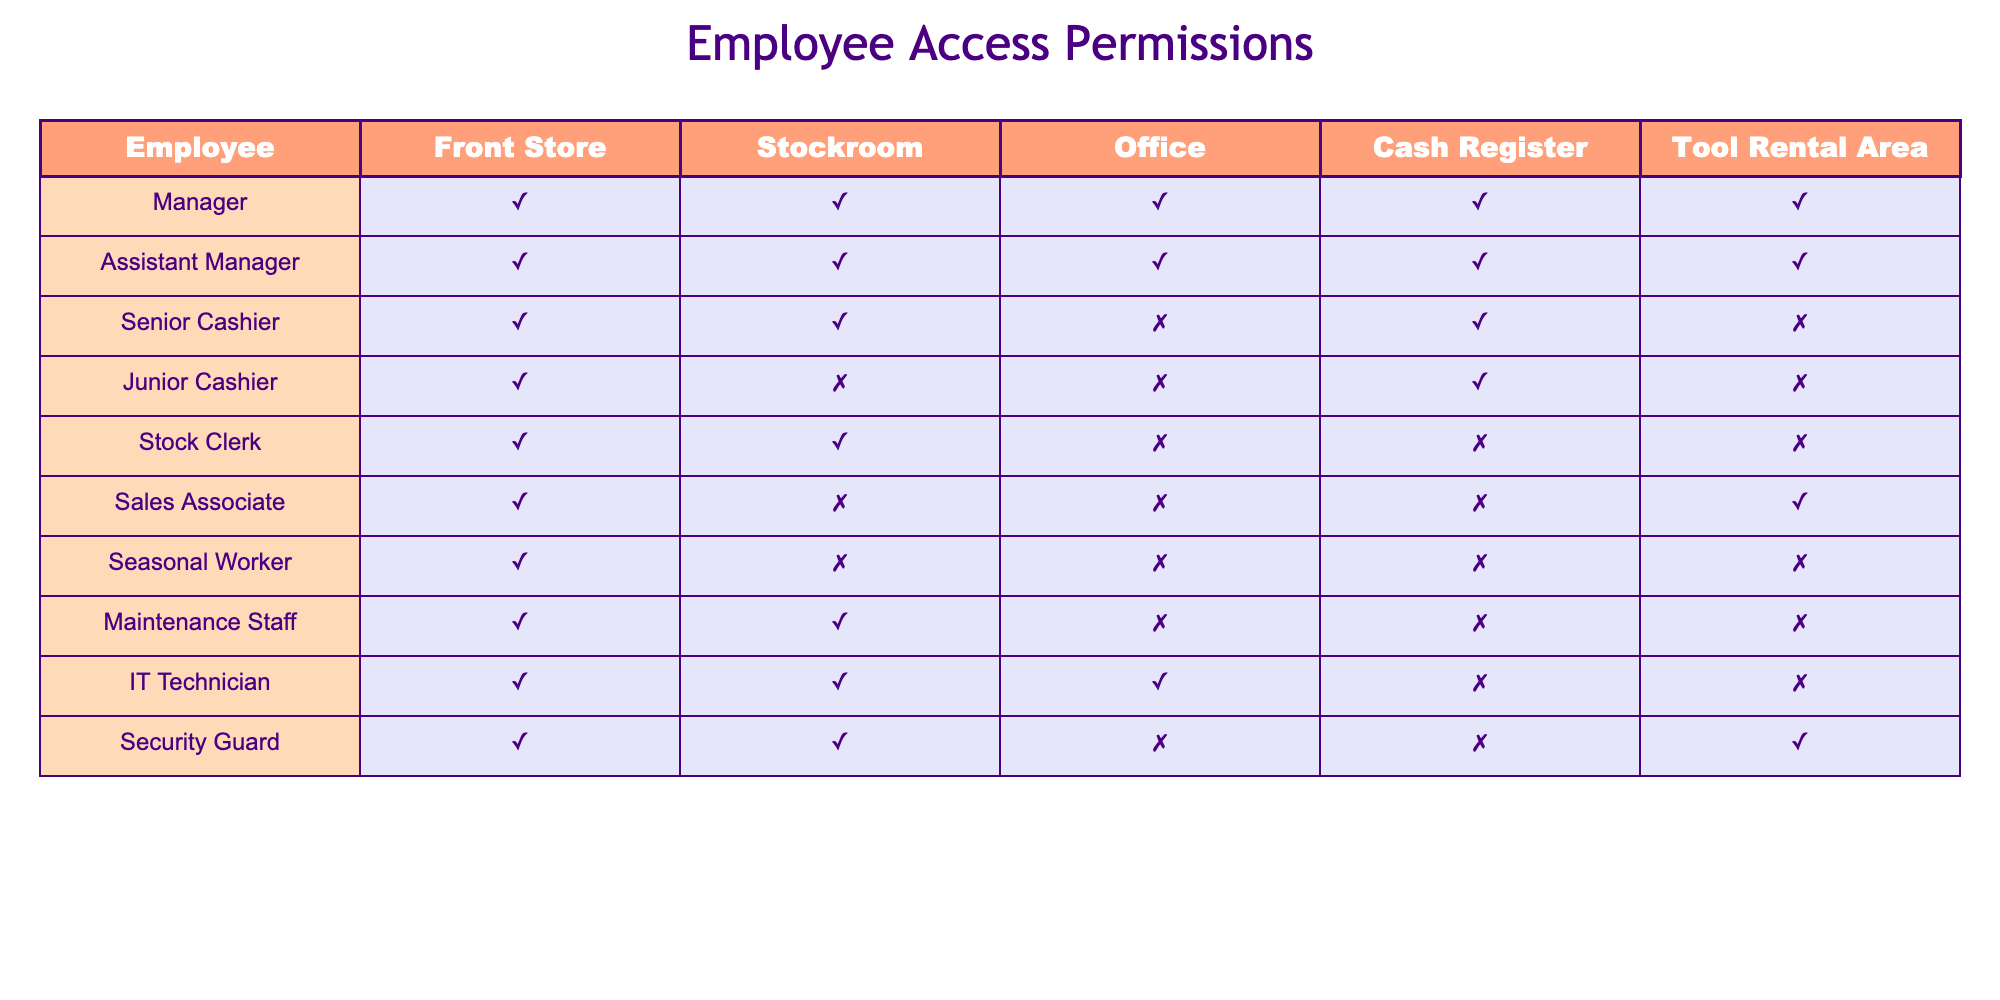What areas can the Senior Cashier access? The table shows that the Senior Cashier has access to the Front Store, Stockroom, and Cash Register, but not to the Office or Tool Rental Area.
Answer: Front Store, Stockroom, Cash Register Does the Security Guard have access to the Tool Rental Area? Looking at the table, the Security Guard has access marked as 'TRUE' for the Tool Rental Area, which means they can access it.
Answer: Yes How many employees can access the Office? From the table, the employees with access to the Office are the Manager, Assistant Manager, and IT Technician. Counting these, we find there are 3 employees.
Answer: 3 Which employee has access to both the Stockroom and the Cash Register? The table indicates that the Manager, Assistant Manager, and Stock Clerk have access to both the Stockroom and the Cash Register. This requires cross-referencing the related columns for those employees.
Answer: Manager, Assistant Manager, Stock Clerk Is the Junior Cashier allowed in the Stockroom? According to the data, the Junior Cashier does not have access to the Stockroom, as indicated by 'FALSE' in that column.
Answer: No Which employee has the most access to areas? By reviewing the table, we see that both the Manager and Assistant Manager have access to all areas, marking 'TRUE' for every access. This requires looking at all permissions for each employee.
Answer: Manager, Assistant Manager How many total areas can the Maintenance Staff access? The Maintenance Staff have access to the Front Store and Stockroom only. Counting those areas gives a total of 2.
Answer: 2 Are there any employees who do not have access to the Cash Register? From the table, the Junior Cashier, Stock Clerk, Seasonal Worker, and the IT Technician do not have access to the Cash Register, as their values are marked 'FALSE'.
Answer: Yes If we combine access to the Front Store and Tool Rental Area, how many unique employees have that access? By reviewing the table, the employees who have access to the Front Store are all employees, while for the Tool Rental Area, only the Manager, Assistant Manager, Sales Associate, and Security Guard do. By combining, the counts need careful cross-checking to ensure uniqueness is maintained. The unique combination results in 8 employees.
Answer: 8 